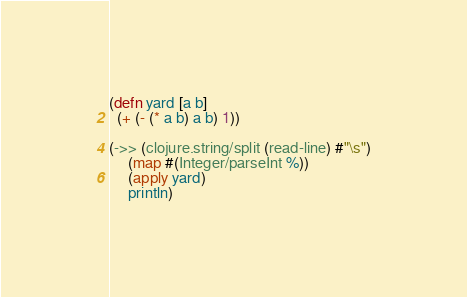Convert code to text. <code><loc_0><loc_0><loc_500><loc_500><_Clojure_>(defn yard [a b]
  (+ (- (* a b) a b) 1))

(->> (clojure.string/split (read-line) #"\s")
     (map #(Integer/parseInt %))
     (apply yard)
     println)</code> 